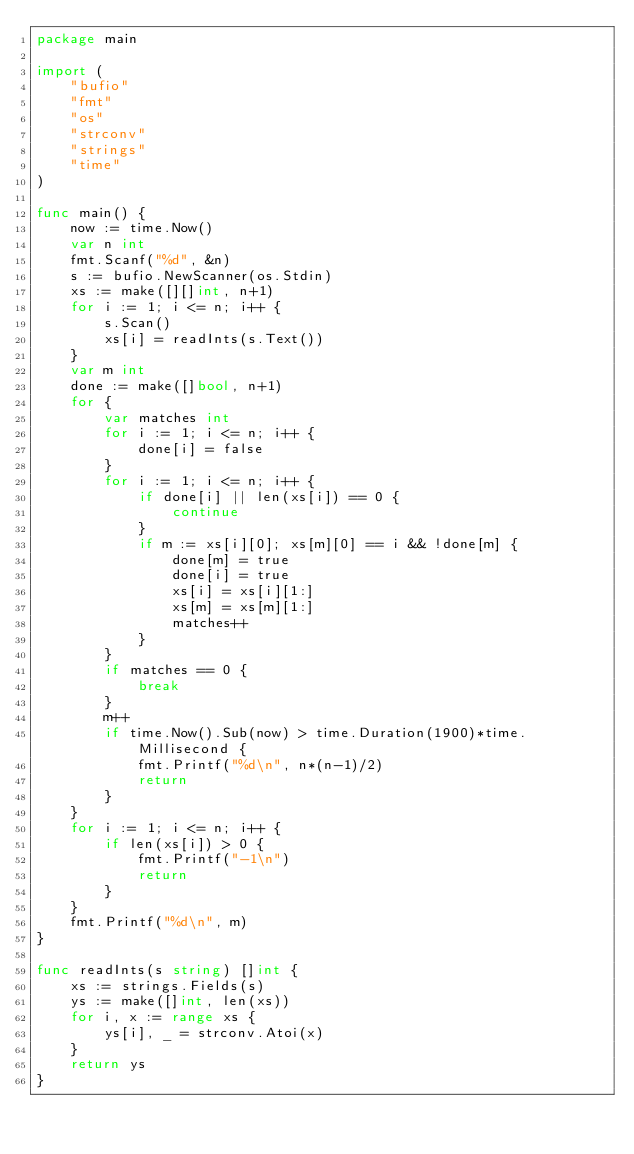Convert code to text. <code><loc_0><loc_0><loc_500><loc_500><_Go_>package main

import (
	"bufio"
	"fmt"
	"os"
	"strconv"
	"strings"
	"time"
)

func main() {
	now := time.Now()
	var n int
	fmt.Scanf("%d", &n)
	s := bufio.NewScanner(os.Stdin)
	xs := make([][]int, n+1)
	for i := 1; i <= n; i++ {
		s.Scan()
		xs[i] = readInts(s.Text())
	}
	var m int
	done := make([]bool, n+1)
	for {
		var matches int
		for i := 1; i <= n; i++ {
			done[i] = false
		}
		for i := 1; i <= n; i++ {
			if done[i] || len(xs[i]) == 0 {
				continue
			}
			if m := xs[i][0]; xs[m][0] == i && !done[m] {
				done[m] = true
				done[i] = true
				xs[i] = xs[i][1:]
				xs[m] = xs[m][1:]
				matches++
			}
		}
		if matches == 0 {
			break
		}
		m++
		if time.Now().Sub(now) > time.Duration(1900)*time.Millisecond {
			fmt.Printf("%d\n", n*(n-1)/2)
			return
		}
	}
	for i := 1; i <= n; i++ {
		if len(xs[i]) > 0 {
			fmt.Printf("-1\n")
			return
		}
	}
	fmt.Printf("%d\n", m)
}

func readInts(s string) []int {
	xs := strings.Fields(s)
	ys := make([]int, len(xs))
	for i, x := range xs {
		ys[i], _ = strconv.Atoi(x)
	}
	return ys
}
</code> 